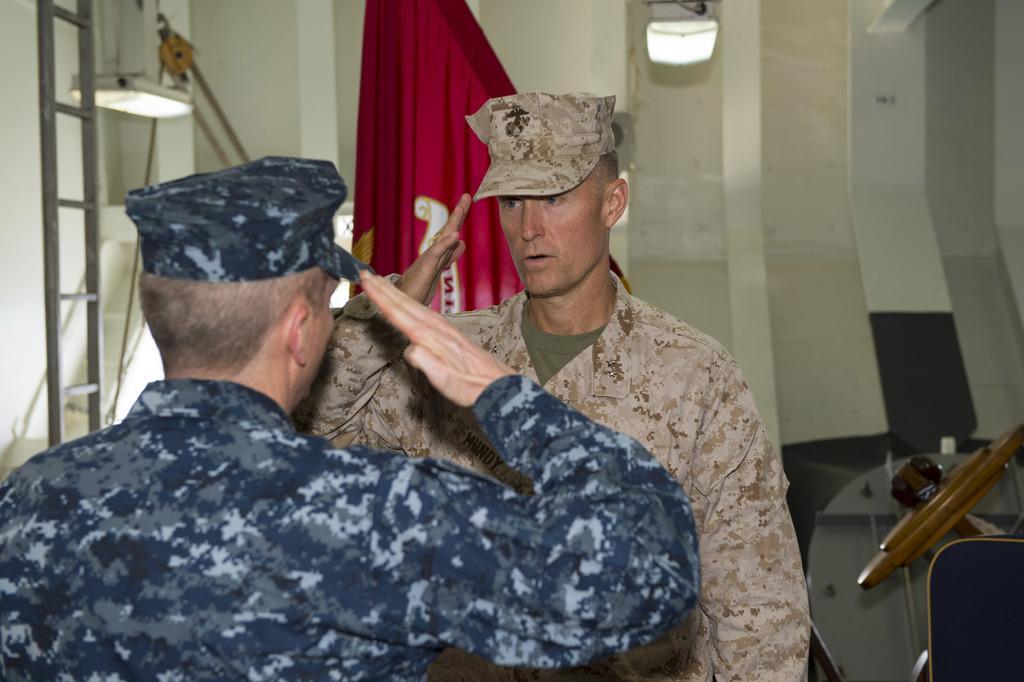Could you give a brief overview of what you see in this image? There are two persons standing in the middle of this image and saluting to each other. There is a wall in the background. There is a cloth is at the top of this image. There is a ladder on the left side of this image and there are some objects on the right side of this image. 